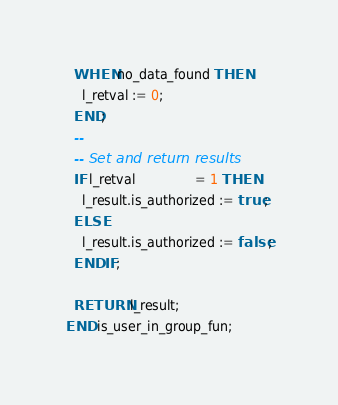Convert code to text. <code><loc_0><loc_0><loc_500><loc_500><_SQL_>  WHEN no_data_found THEN
    l_retval := 0;
  END;
  --
  -- Set and return results
  IF l_retval               = 1 THEN
    l_result.is_authorized := true;
  ELSE
    l_result.is_authorized := false;
  END IF;

  RETURN l_result;
END is_user_in_group_fun;</code> 